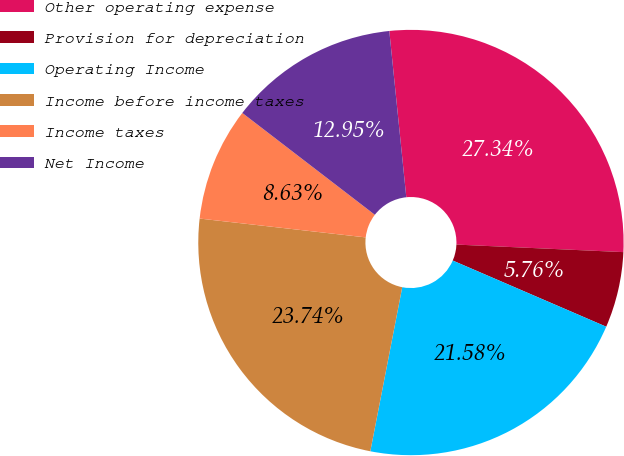Convert chart. <chart><loc_0><loc_0><loc_500><loc_500><pie_chart><fcel>Other operating expense<fcel>Provision for depreciation<fcel>Operating Income<fcel>Income before income taxes<fcel>Income taxes<fcel>Net Income<nl><fcel>27.34%<fcel>5.76%<fcel>21.58%<fcel>23.74%<fcel>8.63%<fcel>12.95%<nl></chart> 